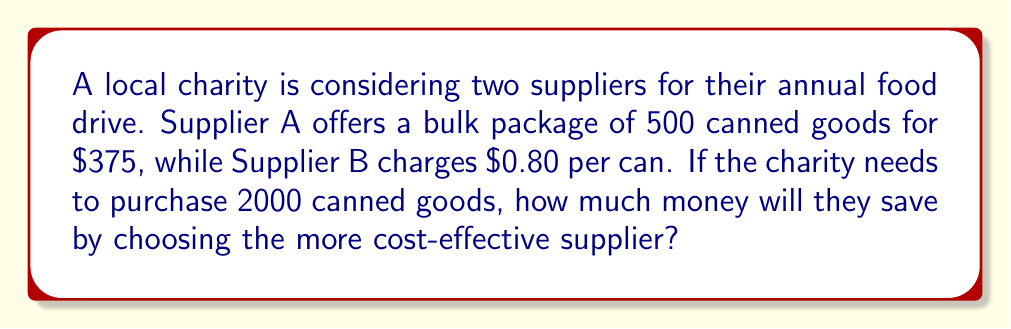Show me your answer to this math problem. Let's approach this step-by-step:

1. Calculate the cost for Supplier A:
   * Each package contains 500 cans and costs $375
   * The charity needs 2000 cans, so they need 4 packages
   * Total cost for Supplier A: $375 × 4 = $1500

2. Calculate the cost for Supplier B:
   * Each can costs $0.80
   * The charity needs 2000 cans
   * Total cost for Supplier B: $0.80 × 2000 = $1600

3. Compare the costs:
   * Supplier A: $1500
   * Supplier B: $1600

4. Calculate the savings:
   * Savings = Cost of more expensive option - Cost of cheaper option
   * Savings = $1600 - $1500 = $100

Therefore, by choosing Supplier A (the more cost-effective option), the charity will save $100.
Answer: $100 